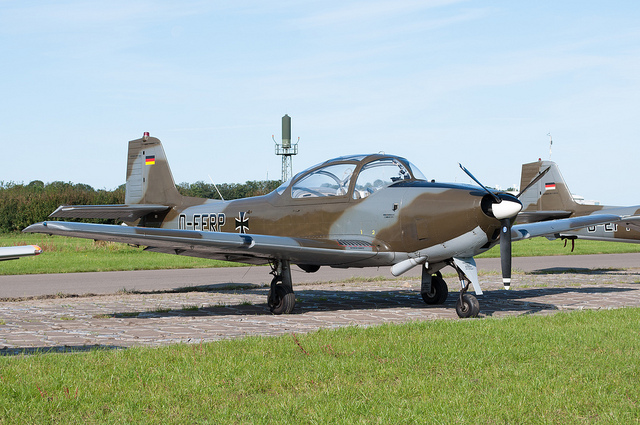Identify and read out the text in this image. D-FERP 